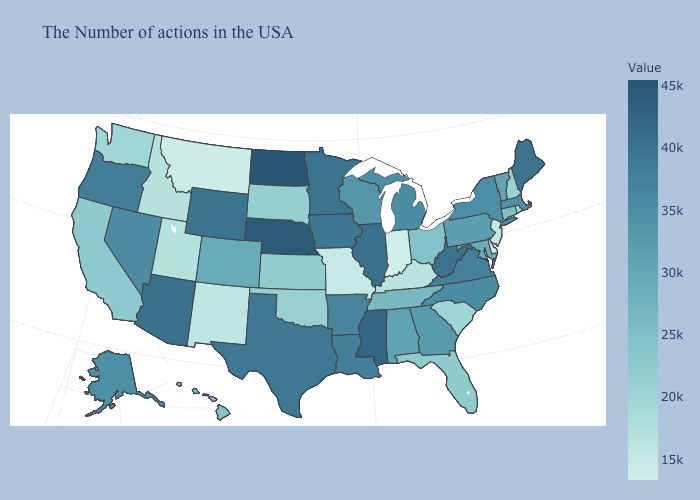Does the map have missing data?
Quick response, please. No. Does the map have missing data?
Give a very brief answer. No. Does Tennessee have a higher value than Missouri?
Concise answer only. Yes. Is the legend a continuous bar?
Write a very short answer. Yes. Among the states that border Ohio , does Michigan have the highest value?
Keep it brief. No. Is the legend a continuous bar?
Give a very brief answer. Yes. 